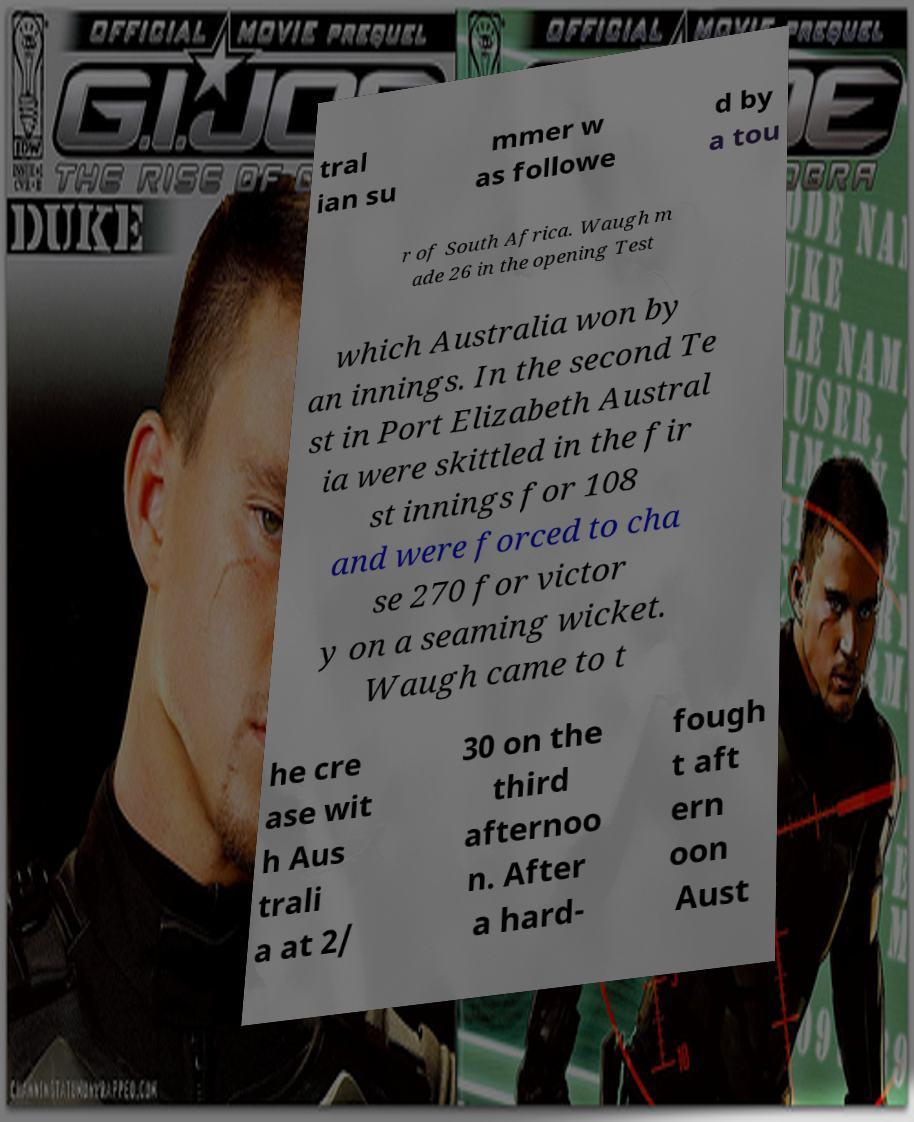Please read and relay the text visible in this image. What does it say? tral ian su mmer w as followe d by a tou r of South Africa. Waugh m ade 26 in the opening Test which Australia won by an innings. In the second Te st in Port Elizabeth Austral ia were skittled in the fir st innings for 108 and were forced to cha se 270 for victor y on a seaming wicket. Waugh came to t he cre ase wit h Aus trali a at 2/ 30 on the third afternoo n. After a hard- fough t aft ern oon Aust 